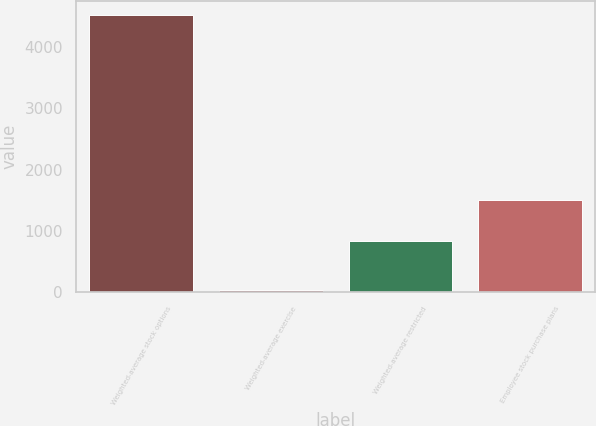Convert chart. <chart><loc_0><loc_0><loc_500><loc_500><bar_chart><fcel>Weighted-average stock options<fcel>Weighted-average exercise<fcel>Weighted-average restricted<fcel>Employee stock purchase plans<nl><fcel>4531<fcel>31.66<fcel>832<fcel>1500<nl></chart> 